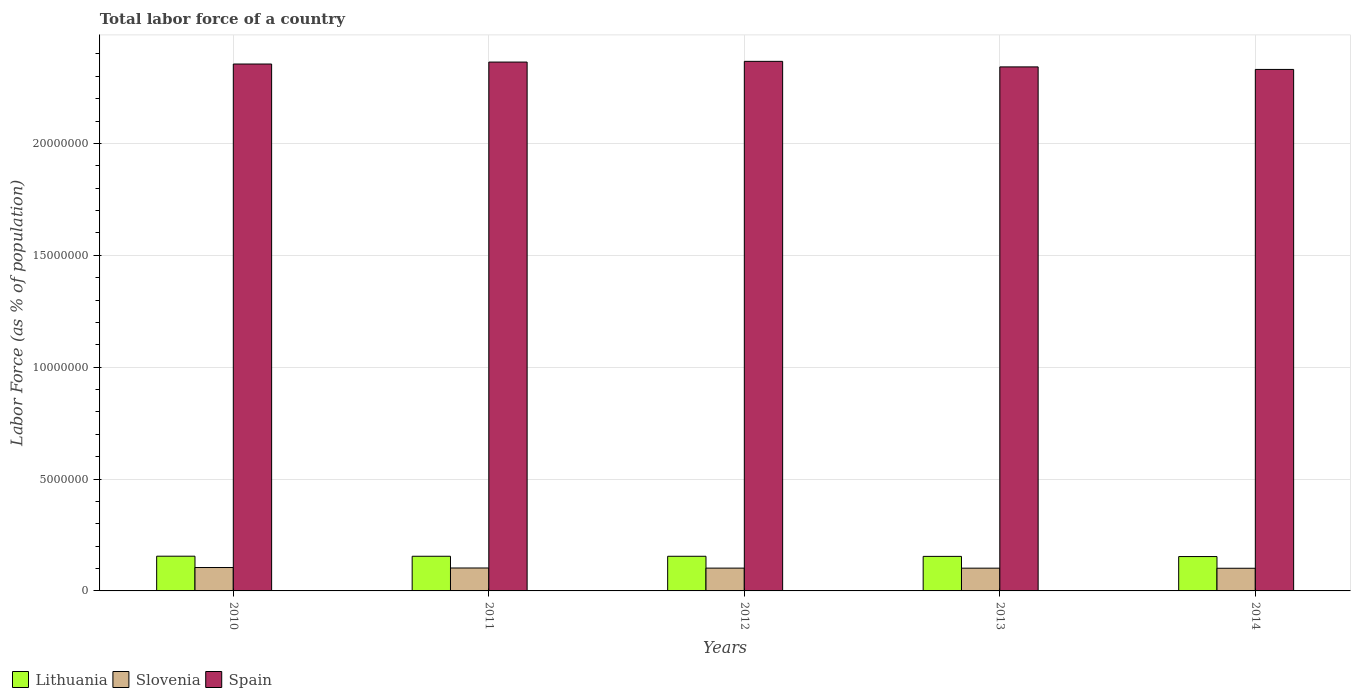Are the number of bars per tick equal to the number of legend labels?
Your answer should be very brief. Yes. How many bars are there on the 2nd tick from the left?
Provide a short and direct response. 3. How many bars are there on the 2nd tick from the right?
Your answer should be compact. 3. What is the percentage of labor force in Lithuania in 2010?
Keep it short and to the point. 1.55e+06. Across all years, what is the maximum percentage of labor force in Slovenia?
Offer a terse response. 1.05e+06. Across all years, what is the minimum percentage of labor force in Lithuania?
Offer a terse response. 1.54e+06. In which year was the percentage of labor force in Slovenia maximum?
Provide a short and direct response. 2010. What is the total percentage of labor force in Slovenia in the graph?
Keep it short and to the point. 5.12e+06. What is the difference between the percentage of labor force in Spain in 2012 and that in 2013?
Provide a short and direct response. 2.47e+05. What is the difference between the percentage of labor force in Slovenia in 2010 and the percentage of labor force in Spain in 2013?
Offer a very short reply. -2.24e+07. What is the average percentage of labor force in Slovenia per year?
Make the answer very short. 1.02e+06. In the year 2013, what is the difference between the percentage of labor force in Spain and percentage of labor force in Slovenia?
Make the answer very short. 2.24e+07. In how many years, is the percentage of labor force in Spain greater than 9000000 %?
Ensure brevity in your answer.  5. What is the ratio of the percentage of labor force in Slovenia in 2012 to that in 2014?
Give a very brief answer. 1.01. Is the difference between the percentage of labor force in Spain in 2010 and 2013 greater than the difference between the percentage of labor force in Slovenia in 2010 and 2013?
Offer a terse response. Yes. What is the difference between the highest and the second highest percentage of labor force in Lithuania?
Your answer should be very brief. 2802. What is the difference between the highest and the lowest percentage of labor force in Lithuania?
Ensure brevity in your answer.  1.61e+04. Is the sum of the percentage of labor force in Slovenia in 2012 and 2014 greater than the maximum percentage of labor force in Lithuania across all years?
Make the answer very short. Yes. What does the 2nd bar from the left in 2013 represents?
Provide a short and direct response. Slovenia. What does the 3rd bar from the right in 2010 represents?
Offer a terse response. Lithuania. How many bars are there?
Make the answer very short. 15. What is the difference between two consecutive major ticks on the Y-axis?
Your answer should be compact. 5.00e+06. Does the graph contain any zero values?
Give a very brief answer. No. What is the title of the graph?
Give a very brief answer. Total labor force of a country. Does "Micronesia" appear as one of the legend labels in the graph?
Give a very brief answer. No. What is the label or title of the X-axis?
Offer a very short reply. Years. What is the label or title of the Y-axis?
Your answer should be compact. Labor Force (as % of population). What is the Labor Force (as % of population) in Lithuania in 2010?
Your answer should be very brief. 1.55e+06. What is the Labor Force (as % of population) of Slovenia in 2010?
Provide a succinct answer. 1.05e+06. What is the Labor Force (as % of population) of Spain in 2010?
Offer a very short reply. 2.35e+07. What is the Labor Force (as % of population) in Lithuania in 2011?
Provide a succinct answer. 1.55e+06. What is the Labor Force (as % of population) in Slovenia in 2011?
Your answer should be compact. 1.02e+06. What is the Labor Force (as % of population) of Spain in 2011?
Offer a terse response. 2.36e+07. What is the Labor Force (as % of population) in Lithuania in 2012?
Your answer should be very brief. 1.55e+06. What is the Labor Force (as % of population) in Slovenia in 2012?
Give a very brief answer. 1.02e+06. What is the Labor Force (as % of population) of Spain in 2012?
Provide a succinct answer. 2.37e+07. What is the Labor Force (as % of population) in Lithuania in 2013?
Keep it short and to the point. 1.54e+06. What is the Labor Force (as % of population) of Slovenia in 2013?
Give a very brief answer. 1.02e+06. What is the Labor Force (as % of population) of Spain in 2013?
Your answer should be very brief. 2.34e+07. What is the Labor Force (as % of population) of Lithuania in 2014?
Give a very brief answer. 1.54e+06. What is the Labor Force (as % of population) of Slovenia in 2014?
Keep it short and to the point. 1.01e+06. What is the Labor Force (as % of population) of Spain in 2014?
Provide a succinct answer. 2.33e+07. Across all years, what is the maximum Labor Force (as % of population) in Lithuania?
Offer a terse response. 1.55e+06. Across all years, what is the maximum Labor Force (as % of population) in Slovenia?
Ensure brevity in your answer.  1.05e+06. Across all years, what is the maximum Labor Force (as % of population) of Spain?
Make the answer very short. 2.37e+07. Across all years, what is the minimum Labor Force (as % of population) in Lithuania?
Provide a succinct answer. 1.54e+06. Across all years, what is the minimum Labor Force (as % of population) in Slovenia?
Make the answer very short. 1.01e+06. Across all years, what is the minimum Labor Force (as % of population) in Spain?
Offer a terse response. 2.33e+07. What is the total Labor Force (as % of population) of Lithuania in the graph?
Offer a very short reply. 7.73e+06. What is the total Labor Force (as % of population) of Slovenia in the graph?
Provide a succinct answer. 5.12e+06. What is the total Labor Force (as % of population) of Spain in the graph?
Your response must be concise. 1.18e+08. What is the difference between the Labor Force (as % of population) of Lithuania in 2010 and that in 2011?
Make the answer very short. 2802. What is the difference between the Labor Force (as % of population) of Slovenia in 2010 and that in 2011?
Make the answer very short. 2.10e+04. What is the difference between the Labor Force (as % of population) of Spain in 2010 and that in 2011?
Give a very brief answer. -8.69e+04. What is the difference between the Labor Force (as % of population) in Lithuania in 2010 and that in 2012?
Offer a terse response. 3624. What is the difference between the Labor Force (as % of population) of Slovenia in 2010 and that in 2012?
Provide a short and direct response. 2.60e+04. What is the difference between the Labor Force (as % of population) in Spain in 2010 and that in 2012?
Your answer should be compact. -1.19e+05. What is the difference between the Labor Force (as % of population) of Lithuania in 2010 and that in 2013?
Provide a short and direct response. 8506. What is the difference between the Labor Force (as % of population) in Slovenia in 2010 and that in 2013?
Offer a terse response. 2.83e+04. What is the difference between the Labor Force (as % of population) of Spain in 2010 and that in 2013?
Give a very brief answer. 1.28e+05. What is the difference between the Labor Force (as % of population) in Lithuania in 2010 and that in 2014?
Make the answer very short. 1.61e+04. What is the difference between the Labor Force (as % of population) of Slovenia in 2010 and that in 2014?
Offer a very short reply. 3.28e+04. What is the difference between the Labor Force (as % of population) in Spain in 2010 and that in 2014?
Provide a succinct answer. 2.42e+05. What is the difference between the Labor Force (as % of population) in Lithuania in 2011 and that in 2012?
Provide a short and direct response. 822. What is the difference between the Labor Force (as % of population) of Slovenia in 2011 and that in 2012?
Make the answer very short. 5018. What is the difference between the Labor Force (as % of population) in Spain in 2011 and that in 2012?
Ensure brevity in your answer.  -3.21e+04. What is the difference between the Labor Force (as % of population) in Lithuania in 2011 and that in 2013?
Your answer should be compact. 5704. What is the difference between the Labor Force (as % of population) of Slovenia in 2011 and that in 2013?
Keep it short and to the point. 7282. What is the difference between the Labor Force (as % of population) of Spain in 2011 and that in 2013?
Ensure brevity in your answer.  2.15e+05. What is the difference between the Labor Force (as % of population) of Lithuania in 2011 and that in 2014?
Provide a short and direct response. 1.33e+04. What is the difference between the Labor Force (as % of population) of Slovenia in 2011 and that in 2014?
Your answer should be very brief. 1.18e+04. What is the difference between the Labor Force (as % of population) in Spain in 2011 and that in 2014?
Give a very brief answer. 3.29e+05. What is the difference between the Labor Force (as % of population) of Lithuania in 2012 and that in 2013?
Offer a very short reply. 4882. What is the difference between the Labor Force (as % of population) of Slovenia in 2012 and that in 2013?
Provide a short and direct response. 2264. What is the difference between the Labor Force (as % of population) of Spain in 2012 and that in 2013?
Make the answer very short. 2.47e+05. What is the difference between the Labor Force (as % of population) of Lithuania in 2012 and that in 2014?
Ensure brevity in your answer.  1.25e+04. What is the difference between the Labor Force (as % of population) of Slovenia in 2012 and that in 2014?
Your answer should be compact. 6760. What is the difference between the Labor Force (as % of population) of Spain in 2012 and that in 2014?
Provide a short and direct response. 3.61e+05. What is the difference between the Labor Force (as % of population) in Lithuania in 2013 and that in 2014?
Your answer should be compact. 7635. What is the difference between the Labor Force (as % of population) of Slovenia in 2013 and that in 2014?
Keep it short and to the point. 4496. What is the difference between the Labor Force (as % of population) in Spain in 2013 and that in 2014?
Offer a terse response. 1.13e+05. What is the difference between the Labor Force (as % of population) in Lithuania in 2010 and the Labor Force (as % of population) in Slovenia in 2011?
Provide a short and direct response. 5.28e+05. What is the difference between the Labor Force (as % of population) of Lithuania in 2010 and the Labor Force (as % of population) of Spain in 2011?
Offer a terse response. -2.21e+07. What is the difference between the Labor Force (as % of population) in Slovenia in 2010 and the Labor Force (as % of population) in Spain in 2011?
Your answer should be compact. -2.26e+07. What is the difference between the Labor Force (as % of population) in Lithuania in 2010 and the Labor Force (as % of population) in Slovenia in 2012?
Give a very brief answer. 5.33e+05. What is the difference between the Labor Force (as % of population) of Lithuania in 2010 and the Labor Force (as % of population) of Spain in 2012?
Ensure brevity in your answer.  -2.21e+07. What is the difference between the Labor Force (as % of population) of Slovenia in 2010 and the Labor Force (as % of population) of Spain in 2012?
Make the answer very short. -2.26e+07. What is the difference between the Labor Force (as % of population) in Lithuania in 2010 and the Labor Force (as % of population) in Slovenia in 2013?
Make the answer very short. 5.35e+05. What is the difference between the Labor Force (as % of population) in Lithuania in 2010 and the Labor Force (as % of population) in Spain in 2013?
Your answer should be compact. -2.19e+07. What is the difference between the Labor Force (as % of population) in Slovenia in 2010 and the Labor Force (as % of population) in Spain in 2013?
Your answer should be very brief. -2.24e+07. What is the difference between the Labor Force (as % of population) in Lithuania in 2010 and the Labor Force (as % of population) in Slovenia in 2014?
Provide a succinct answer. 5.40e+05. What is the difference between the Labor Force (as % of population) of Lithuania in 2010 and the Labor Force (as % of population) of Spain in 2014?
Your answer should be very brief. -2.18e+07. What is the difference between the Labor Force (as % of population) in Slovenia in 2010 and the Labor Force (as % of population) in Spain in 2014?
Your answer should be very brief. -2.23e+07. What is the difference between the Labor Force (as % of population) of Lithuania in 2011 and the Labor Force (as % of population) of Slovenia in 2012?
Make the answer very short. 5.30e+05. What is the difference between the Labor Force (as % of population) of Lithuania in 2011 and the Labor Force (as % of population) of Spain in 2012?
Ensure brevity in your answer.  -2.21e+07. What is the difference between the Labor Force (as % of population) of Slovenia in 2011 and the Labor Force (as % of population) of Spain in 2012?
Offer a terse response. -2.26e+07. What is the difference between the Labor Force (as % of population) of Lithuania in 2011 and the Labor Force (as % of population) of Slovenia in 2013?
Ensure brevity in your answer.  5.32e+05. What is the difference between the Labor Force (as % of population) in Lithuania in 2011 and the Labor Force (as % of population) in Spain in 2013?
Provide a succinct answer. -2.19e+07. What is the difference between the Labor Force (as % of population) of Slovenia in 2011 and the Labor Force (as % of population) of Spain in 2013?
Your response must be concise. -2.24e+07. What is the difference between the Labor Force (as % of population) of Lithuania in 2011 and the Labor Force (as % of population) of Slovenia in 2014?
Make the answer very short. 5.37e+05. What is the difference between the Labor Force (as % of population) of Lithuania in 2011 and the Labor Force (as % of population) of Spain in 2014?
Your response must be concise. -2.18e+07. What is the difference between the Labor Force (as % of population) of Slovenia in 2011 and the Labor Force (as % of population) of Spain in 2014?
Ensure brevity in your answer.  -2.23e+07. What is the difference between the Labor Force (as % of population) of Lithuania in 2012 and the Labor Force (as % of population) of Slovenia in 2013?
Your answer should be very brief. 5.31e+05. What is the difference between the Labor Force (as % of population) in Lithuania in 2012 and the Labor Force (as % of population) in Spain in 2013?
Keep it short and to the point. -2.19e+07. What is the difference between the Labor Force (as % of population) of Slovenia in 2012 and the Labor Force (as % of population) of Spain in 2013?
Keep it short and to the point. -2.24e+07. What is the difference between the Labor Force (as % of population) of Lithuania in 2012 and the Labor Force (as % of population) of Slovenia in 2014?
Offer a very short reply. 5.36e+05. What is the difference between the Labor Force (as % of population) in Lithuania in 2012 and the Labor Force (as % of population) in Spain in 2014?
Give a very brief answer. -2.18e+07. What is the difference between the Labor Force (as % of population) in Slovenia in 2012 and the Labor Force (as % of population) in Spain in 2014?
Provide a succinct answer. -2.23e+07. What is the difference between the Labor Force (as % of population) of Lithuania in 2013 and the Labor Force (as % of population) of Slovenia in 2014?
Provide a short and direct response. 5.31e+05. What is the difference between the Labor Force (as % of population) of Lithuania in 2013 and the Labor Force (as % of population) of Spain in 2014?
Ensure brevity in your answer.  -2.18e+07. What is the difference between the Labor Force (as % of population) in Slovenia in 2013 and the Labor Force (as % of population) in Spain in 2014?
Offer a terse response. -2.23e+07. What is the average Labor Force (as % of population) of Lithuania per year?
Keep it short and to the point. 1.55e+06. What is the average Labor Force (as % of population) of Slovenia per year?
Your response must be concise. 1.02e+06. What is the average Labor Force (as % of population) in Spain per year?
Provide a short and direct response. 2.35e+07. In the year 2010, what is the difference between the Labor Force (as % of population) of Lithuania and Labor Force (as % of population) of Slovenia?
Provide a succinct answer. 5.07e+05. In the year 2010, what is the difference between the Labor Force (as % of population) of Lithuania and Labor Force (as % of population) of Spain?
Your answer should be very brief. -2.20e+07. In the year 2010, what is the difference between the Labor Force (as % of population) in Slovenia and Labor Force (as % of population) in Spain?
Your answer should be compact. -2.25e+07. In the year 2011, what is the difference between the Labor Force (as % of population) in Lithuania and Labor Force (as % of population) in Slovenia?
Give a very brief answer. 5.25e+05. In the year 2011, what is the difference between the Labor Force (as % of population) of Lithuania and Labor Force (as % of population) of Spain?
Give a very brief answer. -2.21e+07. In the year 2011, what is the difference between the Labor Force (as % of population) in Slovenia and Labor Force (as % of population) in Spain?
Give a very brief answer. -2.26e+07. In the year 2012, what is the difference between the Labor Force (as % of population) in Lithuania and Labor Force (as % of population) in Slovenia?
Make the answer very short. 5.29e+05. In the year 2012, what is the difference between the Labor Force (as % of population) of Lithuania and Labor Force (as % of population) of Spain?
Your answer should be very brief. -2.21e+07. In the year 2012, what is the difference between the Labor Force (as % of population) of Slovenia and Labor Force (as % of population) of Spain?
Provide a short and direct response. -2.26e+07. In the year 2013, what is the difference between the Labor Force (as % of population) in Lithuania and Labor Force (as % of population) in Slovenia?
Your response must be concise. 5.27e+05. In the year 2013, what is the difference between the Labor Force (as % of population) of Lithuania and Labor Force (as % of population) of Spain?
Your answer should be very brief. -2.19e+07. In the year 2013, what is the difference between the Labor Force (as % of population) in Slovenia and Labor Force (as % of population) in Spain?
Provide a short and direct response. -2.24e+07. In the year 2014, what is the difference between the Labor Force (as % of population) in Lithuania and Labor Force (as % of population) in Slovenia?
Offer a terse response. 5.23e+05. In the year 2014, what is the difference between the Labor Force (as % of population) of Lithuania and Labor Force (as % of population) of Spain?
Give a very brief answer. -2.18e+07. In the year 2014, what is the difference between the Labor Force (as % of population) of Slovenia and Labor Force (as % of population) of Spain?
Give a very brief answer. -2.23e+07. What is the ratio of the Labor Force (as % of population) of Slovenia in 2010 to that in 2011?
Offer a terse response. 1.02. What is the ratio of the Labor Force (as % of population) in Lithuania in 2010 to that in 2012?
Your response must be concise. 1. What is the ratio of the Labor Force (as % of population) in Slovenia in 2010 to that in 2012?
Give a very brief answer. 1.03. What is the ratio of the Labor Force (as % of population) in Spain in 2010 to that in 2012?
Your answer should be very brief. 0.99. What is the ratio of the Labor Force (as % of population) of Lithuania in 2010 to that in 2013?
Keep it short and to the point. 1.01. What is the ratio of the Labor Force (as % of population) in Slovenia in 2010 to that in 2013?
Your response must be concise. 1.03. What is the ratio of the Labor Force (as % of population) of Spain in 2010 to that in 2013?
Ensure brevity in your answer.  1.01. What is the ratio of the Labor Force (as % of population) in Lithuania in 2010 to that in 2014?
Offer a terse response. 1.01. What is the ratio of the Labor Force (as % of population) of Slovenia in 2010 to that in 2014?
Offer a very short reply. 1.03. What is the ratio of the Labor Force (as % of population) of Spain in 2010 to that in 2014?
Offer a very short reply. 1.01. What is the ratio of the Labor Force (as % of population) in Slovenia in 2011 to that in 2012?
Ensure brevity in your answer.  1. What is the ratio of the Labor Force (as % of population) of Spain in 2011 to that in 2012?
Offer a very short reply. 1. What is the ratio of the Labor Force (as % of population) of Spain in 2011 to that in 2013?
Your answer should be very brief. 1.01. What is the ratio of the Labor Force (as % of population) of Lithuania in 2011 to that in 2014?
Your response must be concise. 1.01. What is the ratio of the Labor Force (as % of population) in Slovenia in 2011 to that in 2014?
Keep it short and to the point. 1.01. What is the ratio of the Labor Force (as % of population) of Spain in 2011 to that in 2014?
Ensure brevity in your answer.  1.01. What is the ratio of the Labor Force (as % of population) of Lithuania in 2012 to that in 2013?
Your answer should be very brief. 1. What is the ratio of the Labor Force (as % of population) of Slovenia in 2012 to that in 2013?
Provide a succinct answer. 1. What is the ratio of the Labor Force (as % of population) of Spain in 2012 to that in 2013?
Offer a terse response. 1.01. What is the ratio of the Labor Force (as % of population) in Lithuania in 2012 to that in 2014?
Offer a terse response. 1.01. What is the ratio of the Labor Force (as % of population) of Slovenia in 2012 to that in 2014?
Give a very brief answer. 1.01. What is the ratio of the Labor Force (as % of population) in Spain in 2012 to that in 2014?
Your answer should be compact. 1.02. What is the ratio of the Labor Force (as % of population) in Lithuania in 2013 to that in 2014?
Provide a short and direct response. 1. What is the ratio of the Labor Force (as % of population) in Spain in 2013 to that in 2014?
Your answer should be very brief. 1. What is the difference between the highest and the second highest Labor Force (as % of population) in Lithuania?
Offer a very short reply. 2802. What is the difference between the highest and the second highest Labor Force (as % of population) of Slovenia?
Ensure brevity in your answer.  2.10e+04. What is the difference between the highest and the second highest Labor Force (as % of population) in Spain?
Make the answer very short. 3.21e+04. What is the difference between the highest and the lowest Labor Force (as % of population) of Lithuania?
Keep it short and to the point. 1.61e+04. What is the difference between the highest and the lowest Labor Force (as % of population) in Slovenia?
Offer a very short reply. 3.28e+04. What is the difference between the highest and the lowest Labor Force (as % of population) in Spain?
Offer a terse response. 3.61e+05. 